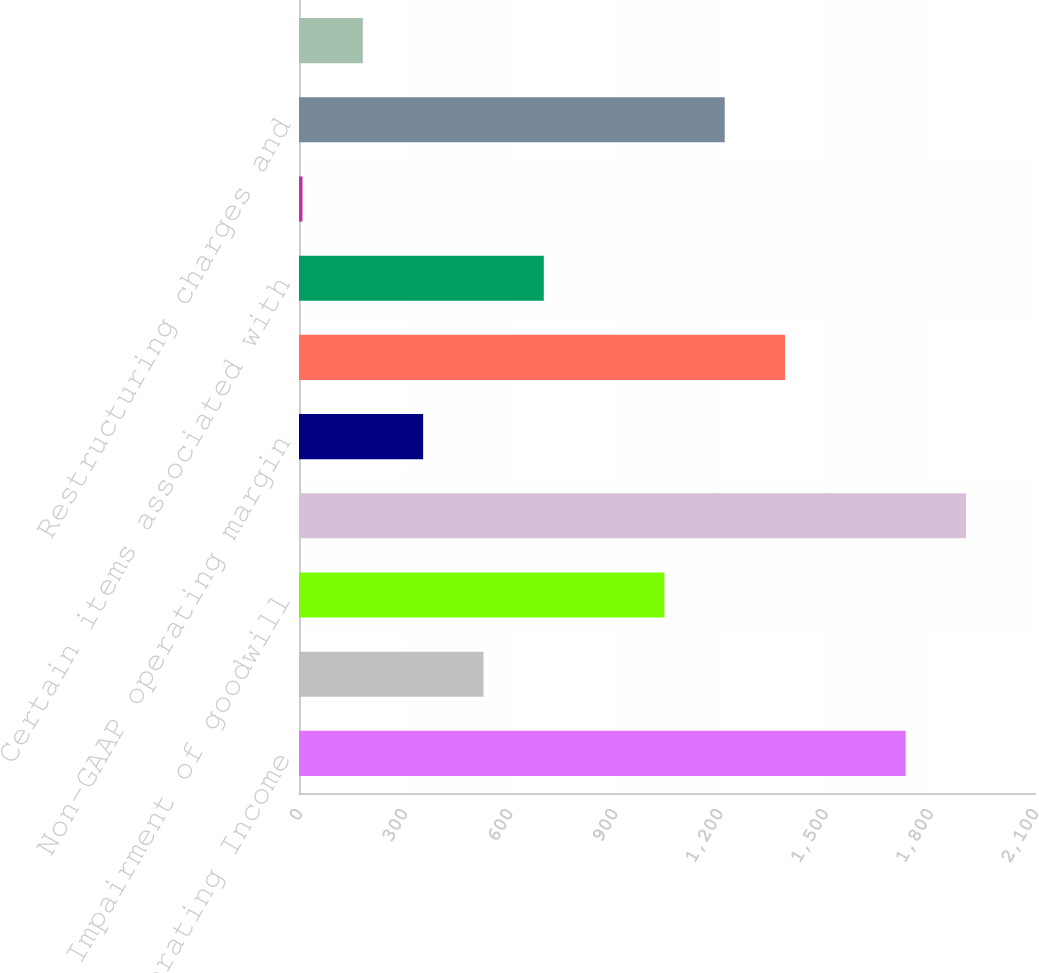<chart> <loc_0><loc_0><loc_500><loc_500><bar_chart><fcel>Non-GAAP Operating Income<fcel>Reported operating income<fcel>Impairment of goodwill<fcel>Non-GAAP operating income<fcel>Non-GAAP operating margin<fcel>Reported net income (GAAP<fcel>Certain items associated with<fcel>Acquisition integration and<fcel>Restructuring charges and<fcel>Impairment of strategic<nl><fcel>1731<fcel>526.3<fcel>1042.6<fcel>1903.1<fcel>354.2<fcel>1386.8<fcel>698.4<fcel>10<fcel>1214.7<fcel>182.1<nl></chart> 